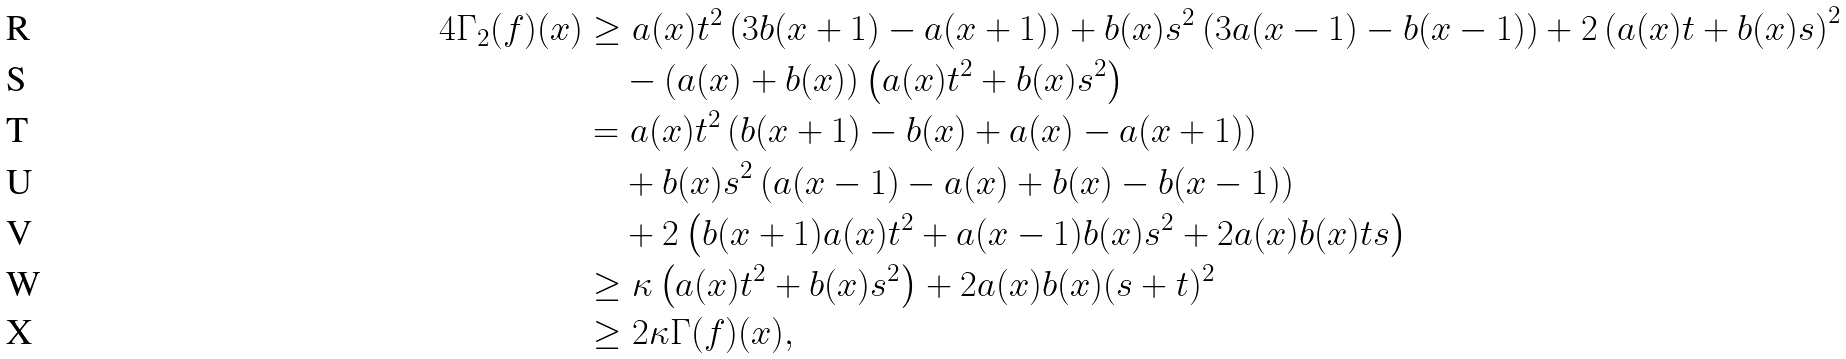Convert formula to latex. <formula><loc_0><loc_0><loc_500><loc_500>4 \Gamma _ { 2 } ( f ) ( x ) & \geq a ( x ) t ^ { 2 } \left ( 3 b ( x + 1 ) - a ( x + 1 ) \right ) + b ( x ) s ^ { 2 } \left ( 3 a ( x - 1 ) - b ( x - 1 ) \right ) + 2 \left ( a ( x ) t + b ( x ) s \right ) ^ { 2 } \\ & \quad - ( a ( x ) + b ( x ) ) \left ( a ( x ) t ^ { 2 } + b ( x ) s ^ { 2 } \right ) \\ & = a ( x ) t ^ { 2 } \left ( b ( x + 1 ) - b ( x ) + a ( x ) - a ( x + 1 ) \right ) \\ & \quad + b ( x ) s ^ { 2 } \left ( a ( x - 1 ) - a ( x ) + b ( x ) - b ( x - 1 ) \right ) \\ & \quad + 2 \left ( b ( x + 1 ) a ( x ) t ^ { 2 } + a ( x - 1 ) b ( x ) s ^ { 2 } + 2 a ( x ) b ( x ) t s \right ) \\ & \geq \kappa \left ( a ( x ) t ^ { 2 } + b ( x ) s ^ { 2 } \right ) + 2 a ( x ) b ( x ) ( s + t ) ^ { 2 } \\ & \geq 2 \kappa \Gamma ( f ) ( x ) ,</formula> 